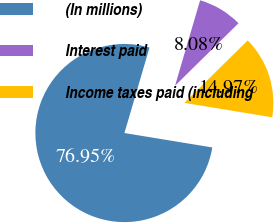Convert chart to OTSL. <chart><loc_0><loc_0><loc_500><loc_500><pie_chart><fcel>(In millions)<fcel>Interest paid<fcel>Income taxes paid (including<nl><fcel>76.95%<fcel>8.08%<fcel>14.97%<nl></chart> 